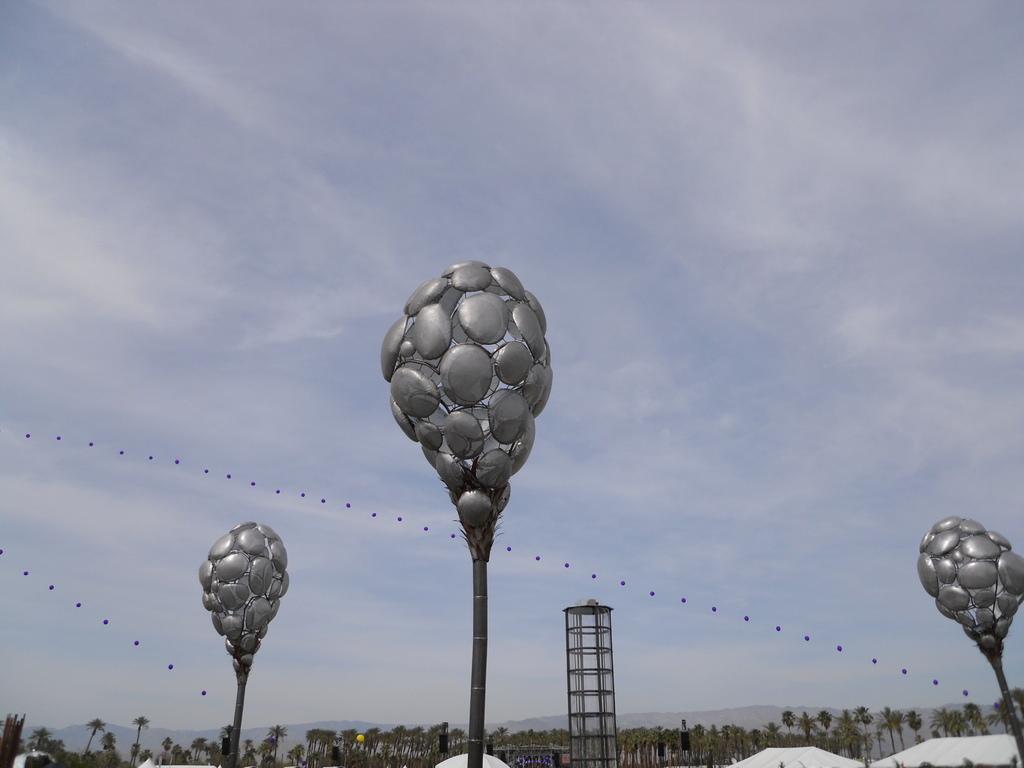Could you give a brief overview of what you see in this image? This picture is clicked outside. In the foreground we can see the tents and some metal objects and we can see the metal rods. In the background we can see the trees, hills, sky and the balloons like objects in the sky. 